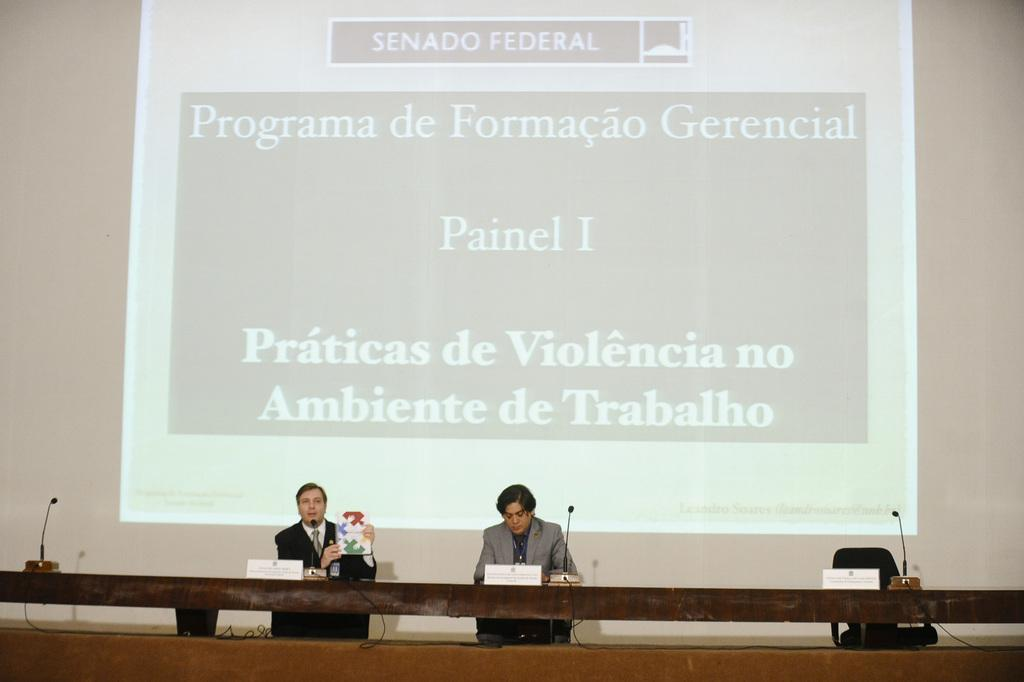How many people are in the image? There are two men in the image. What are the men doing in the image? The men are sitting on chairs. Where are the chairs located in relation to the table? The chairs are near a table. What items can be seen on the table? There are name plates and microphones on the table. What is visible in the background of the image? There is a projector screen in the background. What type of test is being conducted on the stage in the image? There is no stage present in the image, and no test is being conducted. 